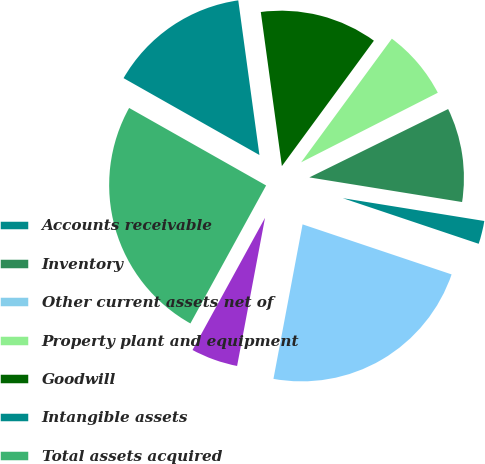Convert chart. <chart><loc_0><loc_0><loc_500><loc_500><pie_chart><fcel>Accounts receivable<fcel>Inventory<fcel>Other current assets net of<fcel>Property plant and equipment<fcel>Goodwill<fcel>Intangible assets<fcel>Total assets acquired<fcel>Total liabilities assumed<fcel>Net assets acquired<nl><fcel>2.61%<fcel>9.83%<fcel>0.21%<fcel>7.43%<fcel>12.24%<fcel>14.64%<fcel>25.21%<fcel>5.02%<fcel>22.81%<nl></chart> 